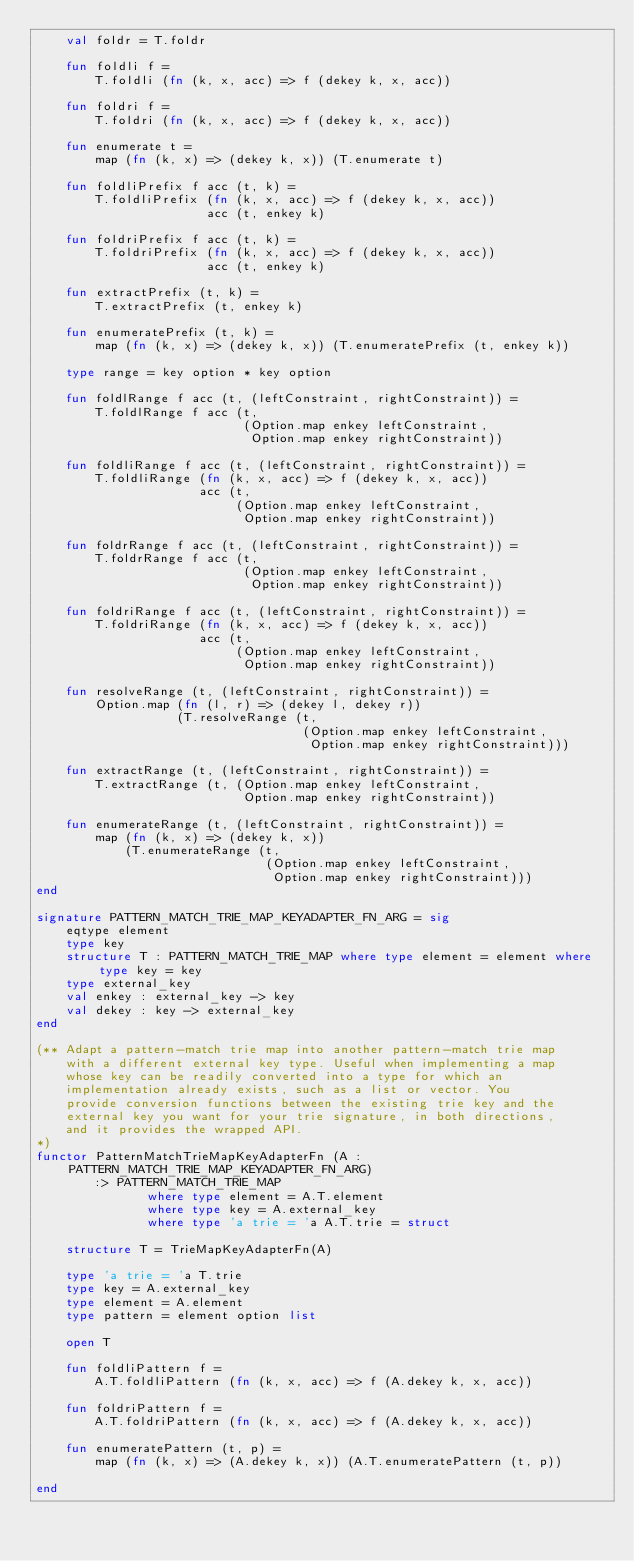Convert code to text. <code><loc_0><loc_0><loc_500><loc_500><_SML_>    val foldr = T.foldr

    fun foldli f =
        T.foldli (fn (k, x, acc) => f (dekey k, x, acc))

    fun foldri f =
        T.foldri (fn (k, x, acc) => f (dekey k, x, acc))

    fun enumerate t =
        map (fn (k, x) => (dekey k, x)) (T.enumerate t)

    fun foldliPrefix f acc (t, k) =
        T.foldliPrefix (fn (k, x, acc) => f (dekey k, x, acc))
                       acc (t, enkey k)

    fun foldriPrefix f acc (t, k) =
        T.foldriPrefix (fn (k, x, acc) => f (dekey k, x, acc))
                       acc (t, enkey k)

    fun extractPrefix (t, k) =
        T.extractPrefix (t, enkey k)
                       
    fun enumeratePrefix (t, k) =
        map (fn (k, x) => (dekey k, x)) (T.enumeratePrefix (t, enkey k))

    type range = key option * key option

    fun foldlRange f acc (t, (leftConstraint, rightConstraint)) =
        T.foldlRange f acc (t,
                            (Option.map enkey leftConstraint,
                             Option.map enkey rightConstraint))

    fun foldliRange f acc (t, (leftConstraint, rightConstraint)) =
        T.foldliRange (fn (k, x, acc) => f (dekey k, x, acc))
                      acc (t,
                           (Option.map enkey leftConstraint,
                            Option.map enkey rightConstraint))

    fun foldrRange f acc (t, (leftConstraint, rightConstraint)) =
        T.foldrRange f acc (t,
                            (Option.map enkey leftConstraint,
                             Option.map enkey rightConstraint))

    fun foldriRange f acc (t, (leftConstraint, rightConstraint)) =
        T.foldriRange (fn (k, x, acc) => f (dekey k, x, acc))
                      acc (t,
                           (Option.map enkey leftConstraint,
                            Option.map enkey rightConstraint))

    fun resolveRange (t, (leftConstraint, rightConstraint)) =
        Option.map (fn (l, r) => (dekey l, dekey r))
                   (T.resolveRange (t,
                                    (Option.map enkey leftConstraint,
                                     Option.map enkey rightConstraint)))
                      
    fun extractRange (t, (leftConstraint, rightConstraint)) =
        T.extractRange (t, (Option.map enkey leftConstraint,
                            Option.map enkey rightConstraint))
                      
    fun enumerateRange (t, (leftConstraint, rightConstraint)) =
        map (fn (k, x) => (dekey k, x))
            (T.enumerateRange (t,
                               (Option.map enkey leftConstraint,
                                Option.map enkey rightConstraint)))
end

signature PATTERN_MATCH_TRIE_MAP_KEYADAPTER_FN_ARG = sig
    eqtype element
    type key
    structure T : PATTERN_MATCH_TRIE_MAP where type element = element where type key = key
    type external_key
    val enkey : external_key -> key
    val dekey : key -> external_key
end

(** Adapt a pattern-match trie map into another pattern-match trie map
    with a different external key type. Useful when implementing a map
    whose key can be readily converted into a type for which an
    implementation already exists, such as a list or vector. You
    provide conversion functions between the existing trie key and the
    external key you want for your trie signature, in both directions,
    and it provides the wrapped API.
*)
functor PatternMatchTrieMapKeyAdapterFn (A : PATTERN_MATCH_TRIE_MAP_KEYADAPTER_FN_ARG)
        :> PATTERN_MATCH_TRIE_MAP
               where type element = A.T.element
               where type key = A.external_key
               where type 'a trie = 'a A.T.trie = struct

    structure T = TrieMapKeyAdapterFn(A)
                      
    type 'a trie = 'a T.trie
    type key = A.external_key
    type element = A.element
    type pattern = element option list
                           
    open T 

    fun foldliPattern f =
        A.T.foldliPattern (fn (k, x, acc) => f (A.dekey k, x, acc))

    fun foldriPattern f =
        A.T.foldriPattern (fn (k, x, acc) => f (A.dekey k, x, acc))

    fun enumeratePattern (t, p) =
        map (fn (k, x) => (A.dekey k, x)) (A.T.enumeratePattern (t, p))
                             
end
</code> 